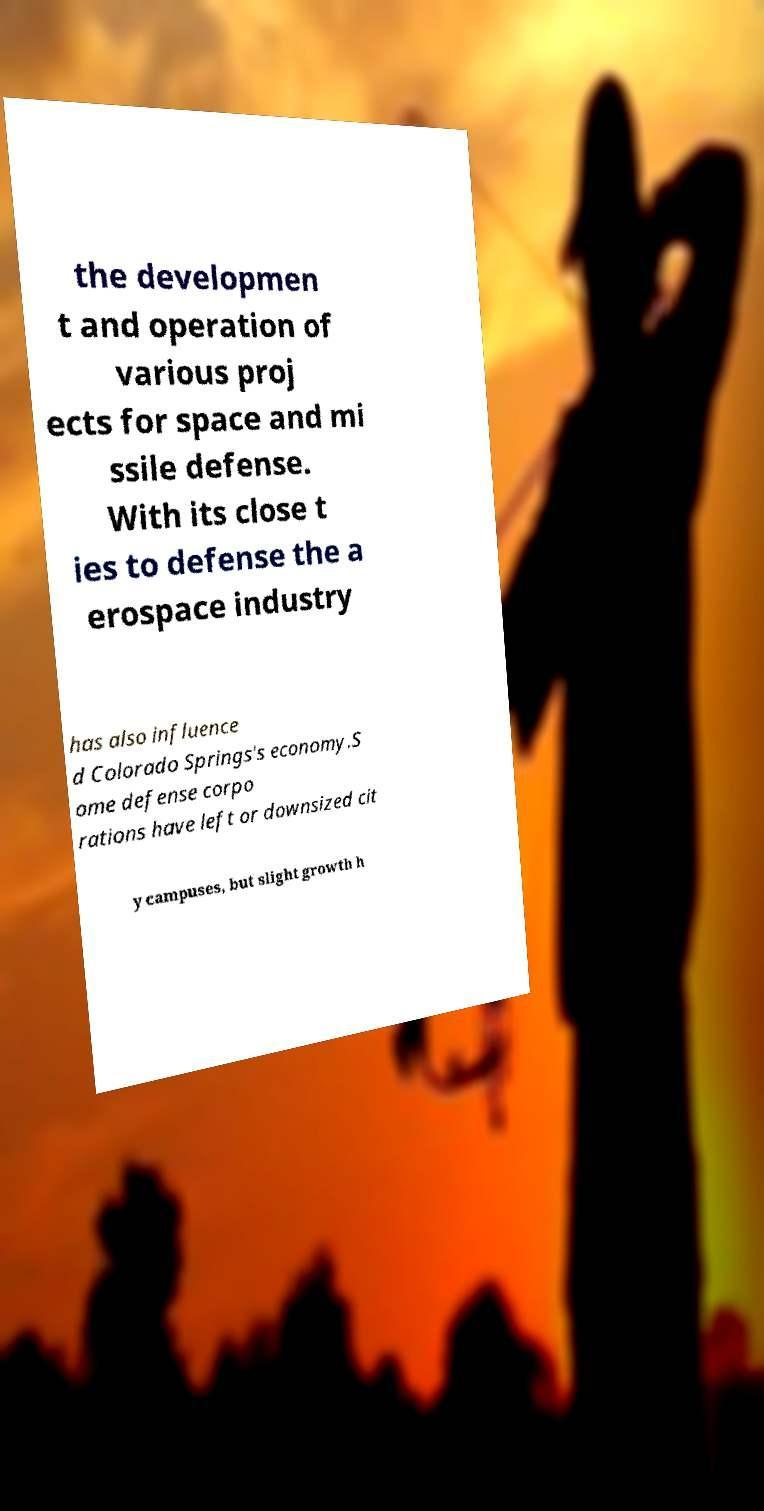There's text embedded in this image that I need extracted. Can you transcribe it verbatim? the developmen t and operation of various proj ects for space and mi ssile defense. With its close t ies to defense the a erospace industry has also influence d Colorado Springs's economy.S ome defense corpo rations have left or downsized cit y campuses, but slight growth h 